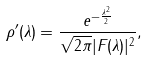Convert formula to latex. <formula><loc_0><loc_0><loc_500><loc_500>\rho ^ { \prime } ( \lambda ) = \frac { e ^ { - \frac { \lambda ^ { 2 } } 2 } } { \sqrt { 2 \pi } | F ( \lambda ) | ^ { 2 } } ,</formula> 